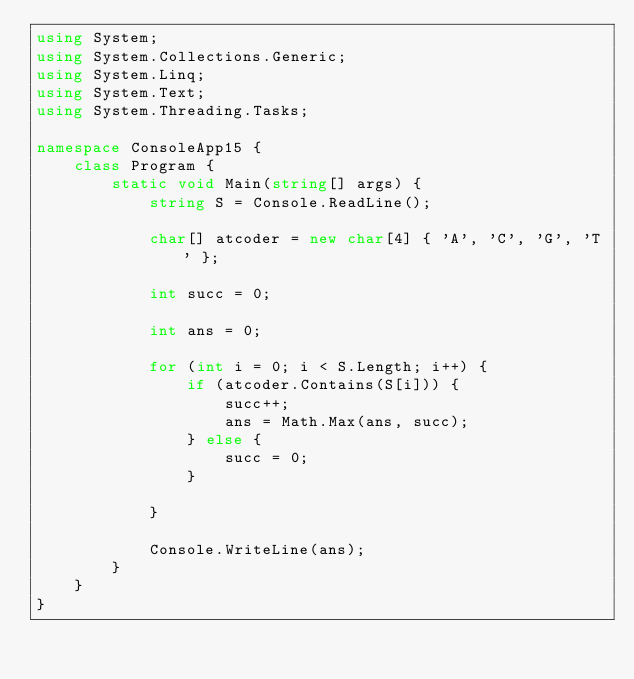Convert code to text. <code><loc_0><loc_0><loc_500><loc_500><_C#_>using System;
using System.Collections.Generic;
using System.Linq;
using System.Text;
using System.Threading.Tasks;

namespace ConsoleApp15 {
    class Program {
        static void Main(string[] args) {
            string S = Console.ReadLine();

            char[] atcoder = new char[4] { 'A', 'C', 'G', 'T' };

            int succ = 0;

            int ans = 0;

            for (int i = 0; i < S.Length; i++) {
                if (atcoder.Contains(S[i])) {
                    succ++;
                    ans = Math.Max(ans, succ);
                } else {
                    succ = 0;
                }

            }

            Console.WriteLine(ans);
        }
    }
}
</code> 